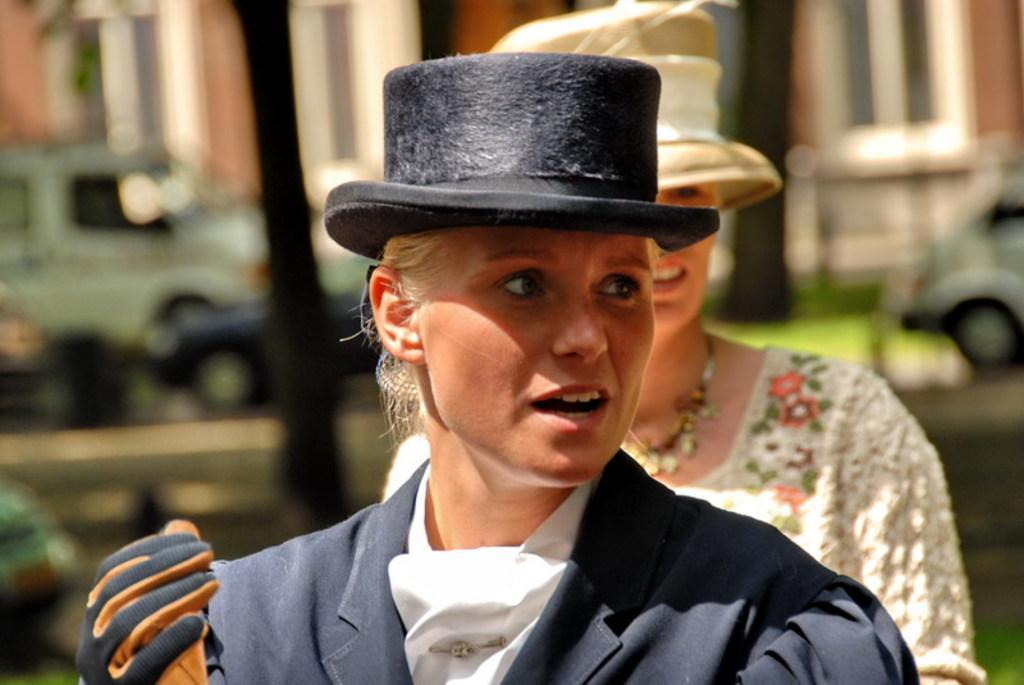How would you summarize this image in a sentence or two? In this picture we can observe two women. One of them is wearing a coat, glove and a black color hat on her head. In the background we can observe vehicles and building. 